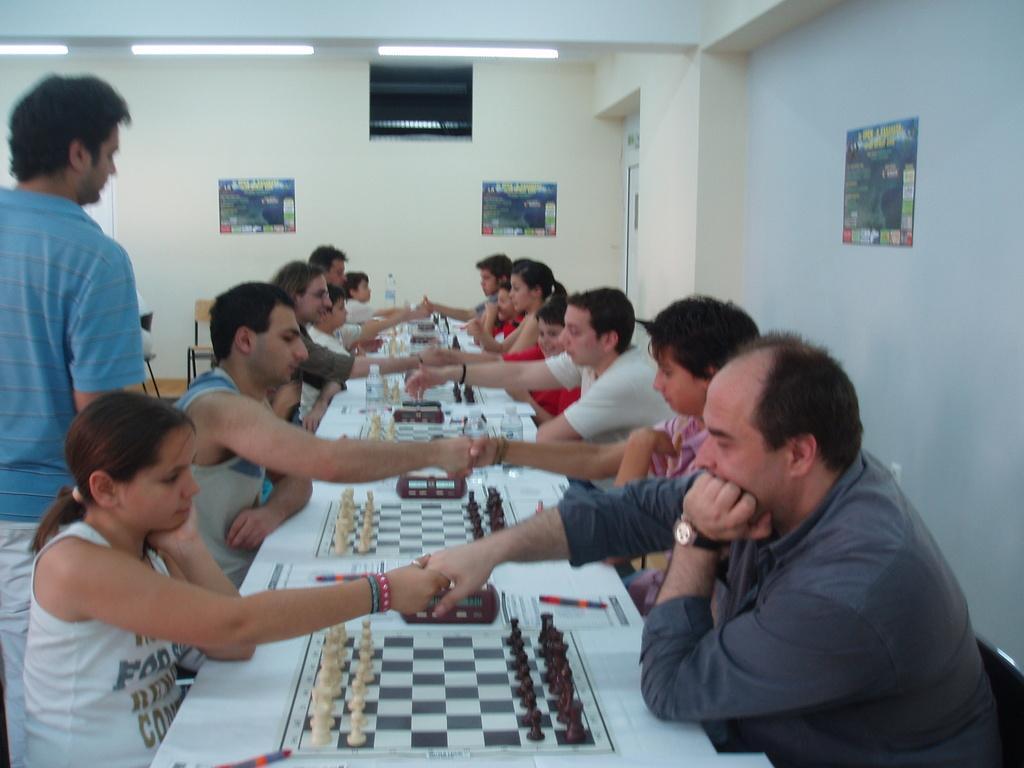Could you give a brief overview of what you see in this image? In this image i can see group of people sitting on chair and playing chess at left there is a man standing at the back ground i can see a poster on the wall and a light. 